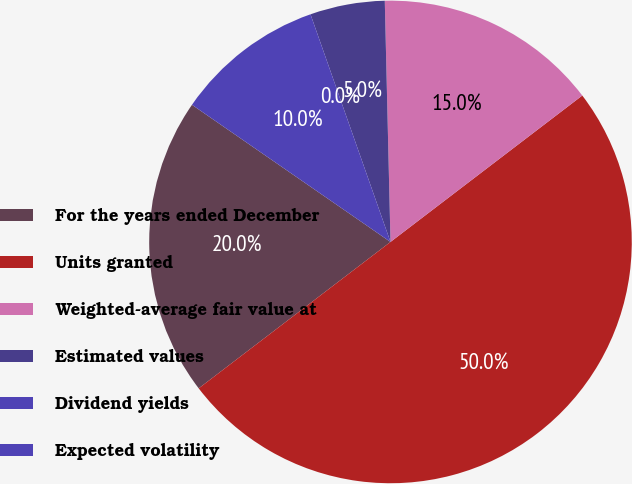Convert chart. <chart><loc_0><loc_0><loc_500><loc_500><pie_chart><fcel>For the years ended December<fcel>Units granted<fcel>Weighted-average fair value at<fcel>Estimated values<fcel>Dividend yields<fcel>Expected volatility<nl><fcel>20.0%<fcel>50.0%<fcel>15.0%<fcel>5.0%<fcel>0.0%<fcel>10.0%<nl></chart> 